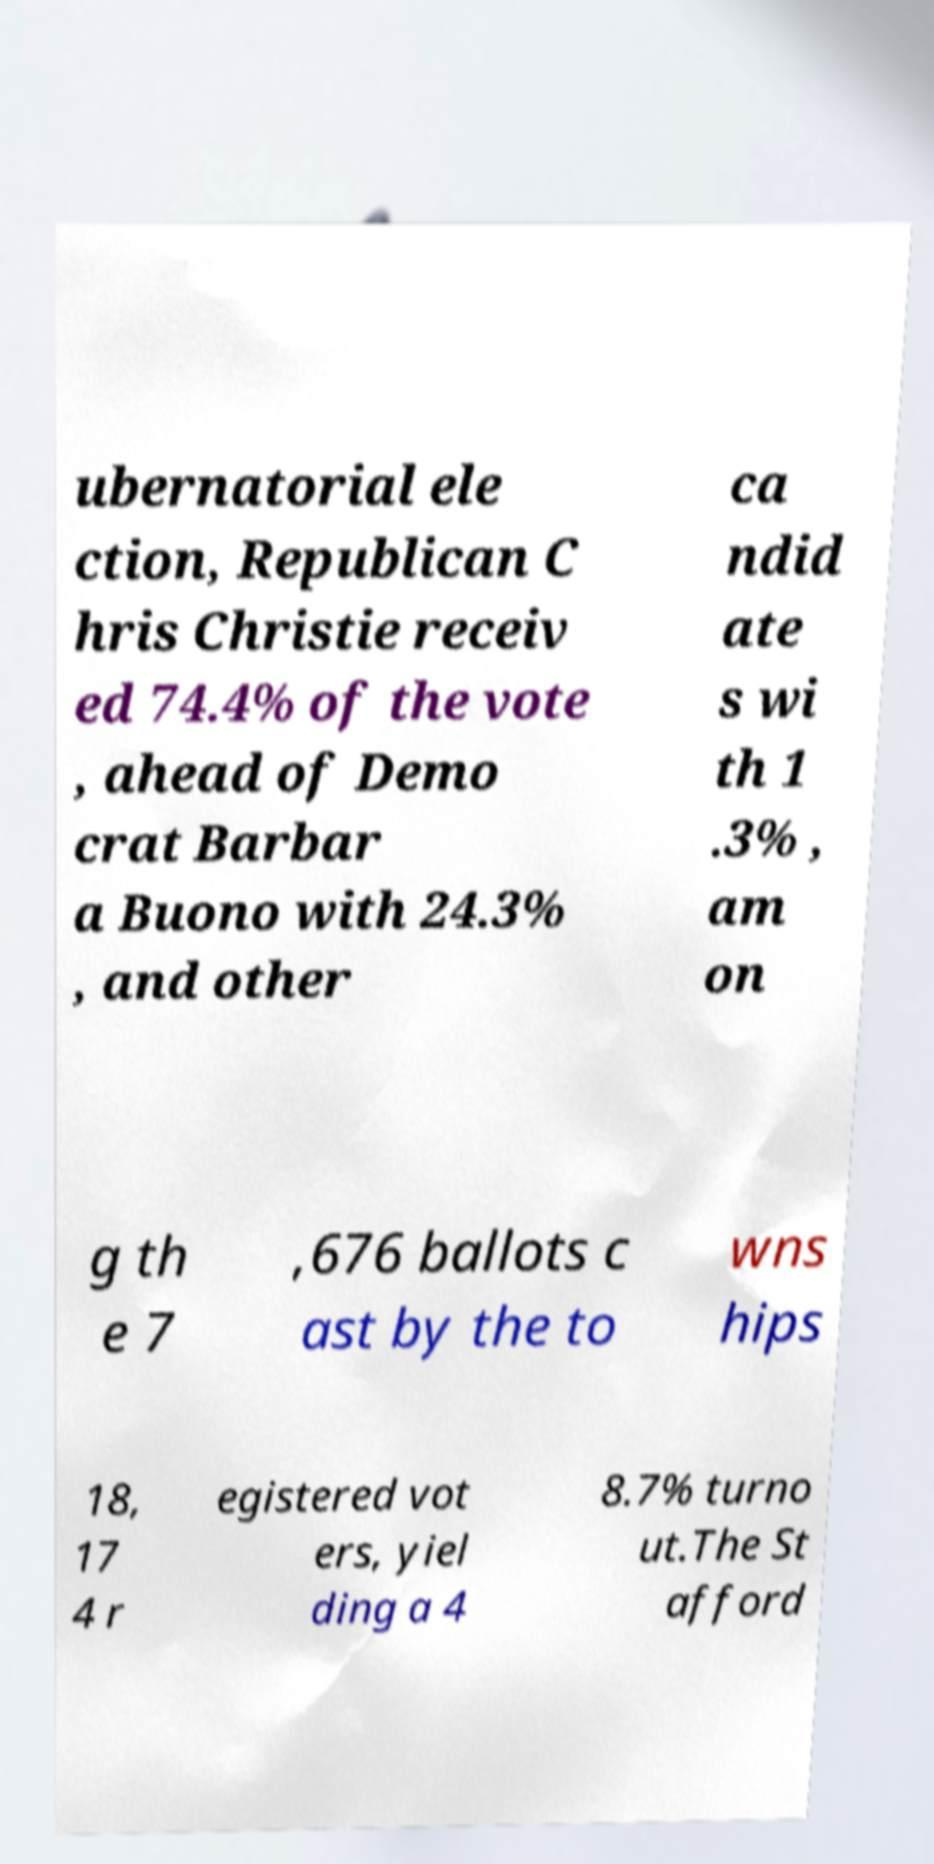Can you read and provide the text displayed in the image?This photo seems to have some interesting text. Can you extract and type it out for me? ubernatorial ele ction, Republican C hris Christie receiv ed 74.4% of the vote , ahead of Demo crat Barbar a Buono with 24.3% , and other ca ndid ate s wi th 1 .3% , am on g th e 7 ,676 ballots c ast by the to wns hips 18, 17 4 r egistered vot ers, yiel ding a 4 8.7% turno ut.The St afford 